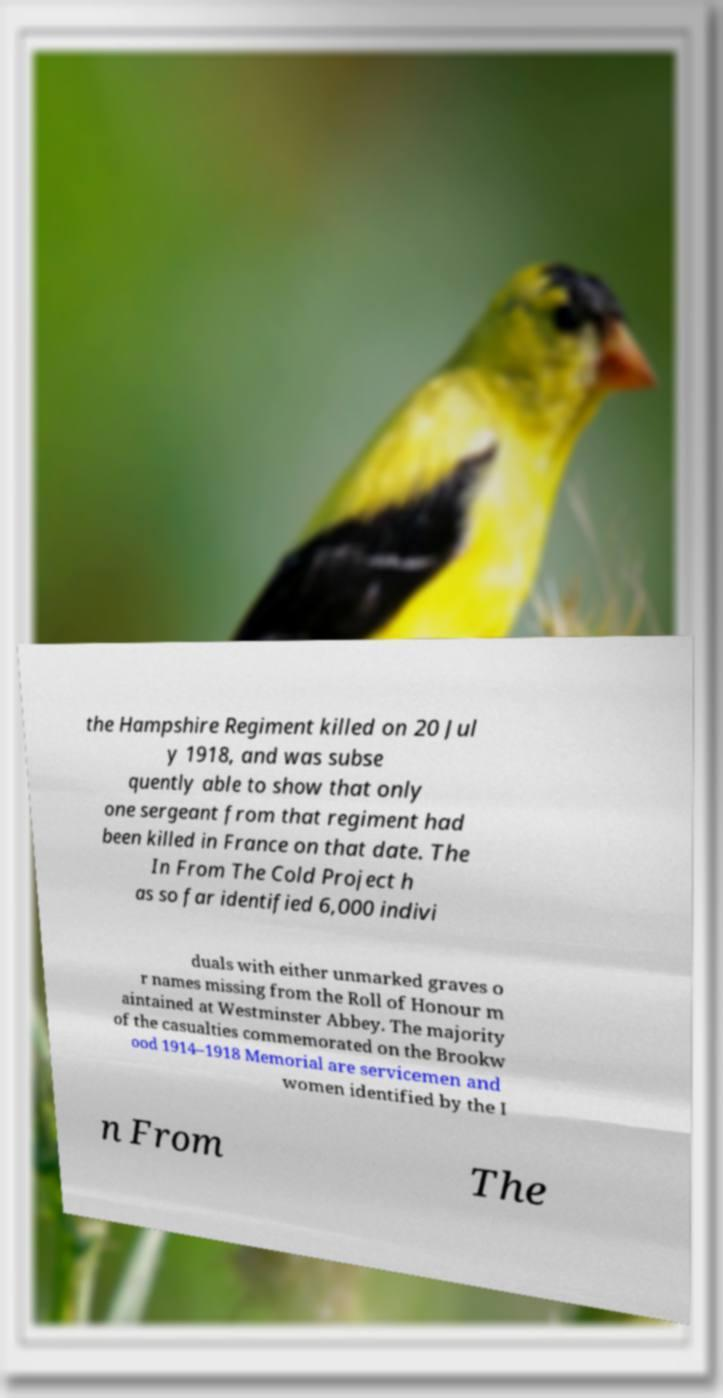Can you accurately transcribe the text from the provided image for me? the Hampshire Regiment killed on 20 Jul y 1918, and was subse quently able to show that only one sergeant from that regiment had been killed in France on that date. The In From The Cold Project h as so far identified 6,000 indivi duals with either unmarked graves o r names missing from the Roll of Honour m aintained at Westminster Abbey. The majority of the casualties commemorated on the Brookw ood 1914–1918 Memorial are servicemen and women identified by the I n From The 